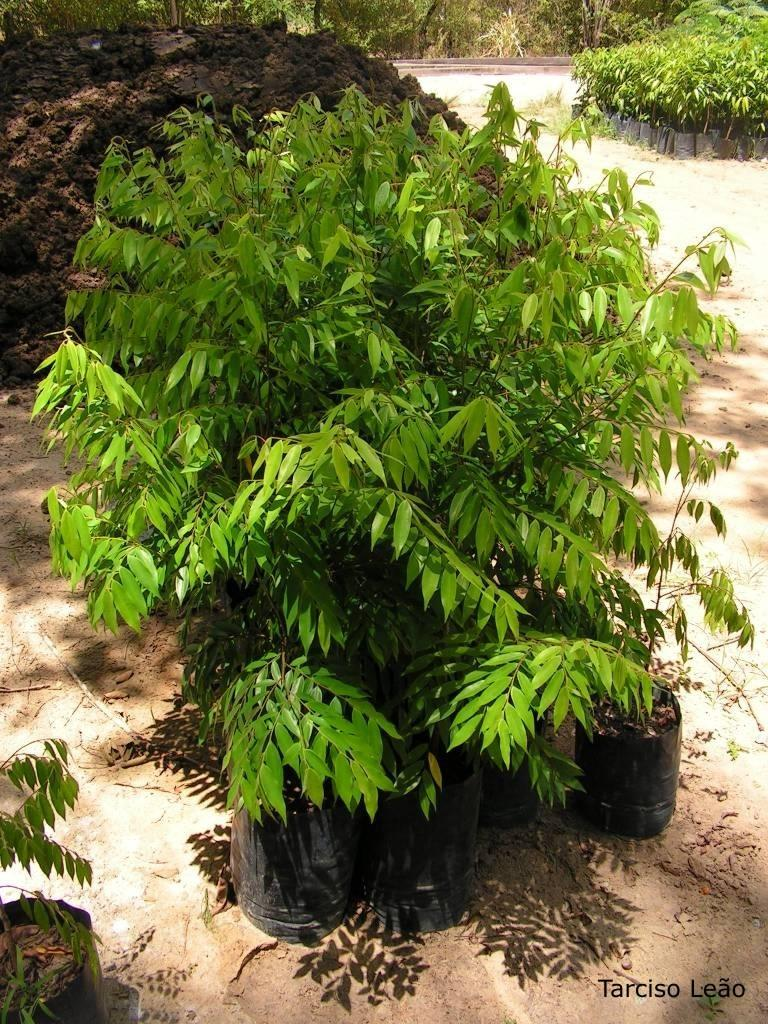What type of living organisms can be seen in the image? Plants can be seen in the image. What is the color of the soil in the backdrop? The soil in the backdrop is black. How many plants are on the right side of the image? There are more plants on the right side of the image. What type of vegetation is visible in the backdrop? Trees are visible in the backdrop of the image. What type of pets can be seen playing with things in the image? There are no pets or things visible in the image; it features plants and black soil. 